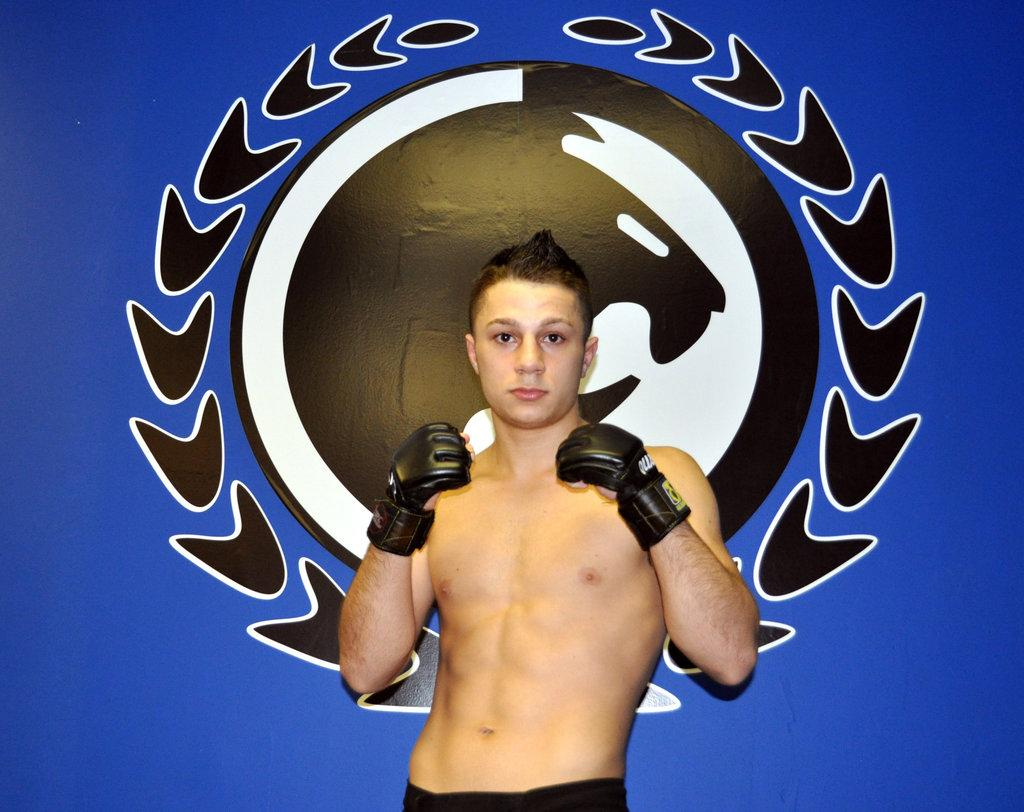What is the main subject of the image? There is a person standing in the image. What color is the background of the image? The background of the image is blue. Is there any additional detail on the background? Yes, there is an image printed on the background. What type of leather is being traded in the image? There is no mention of leather or trading in the image; it features a person standing in front of a blue background with an image printed on it. 